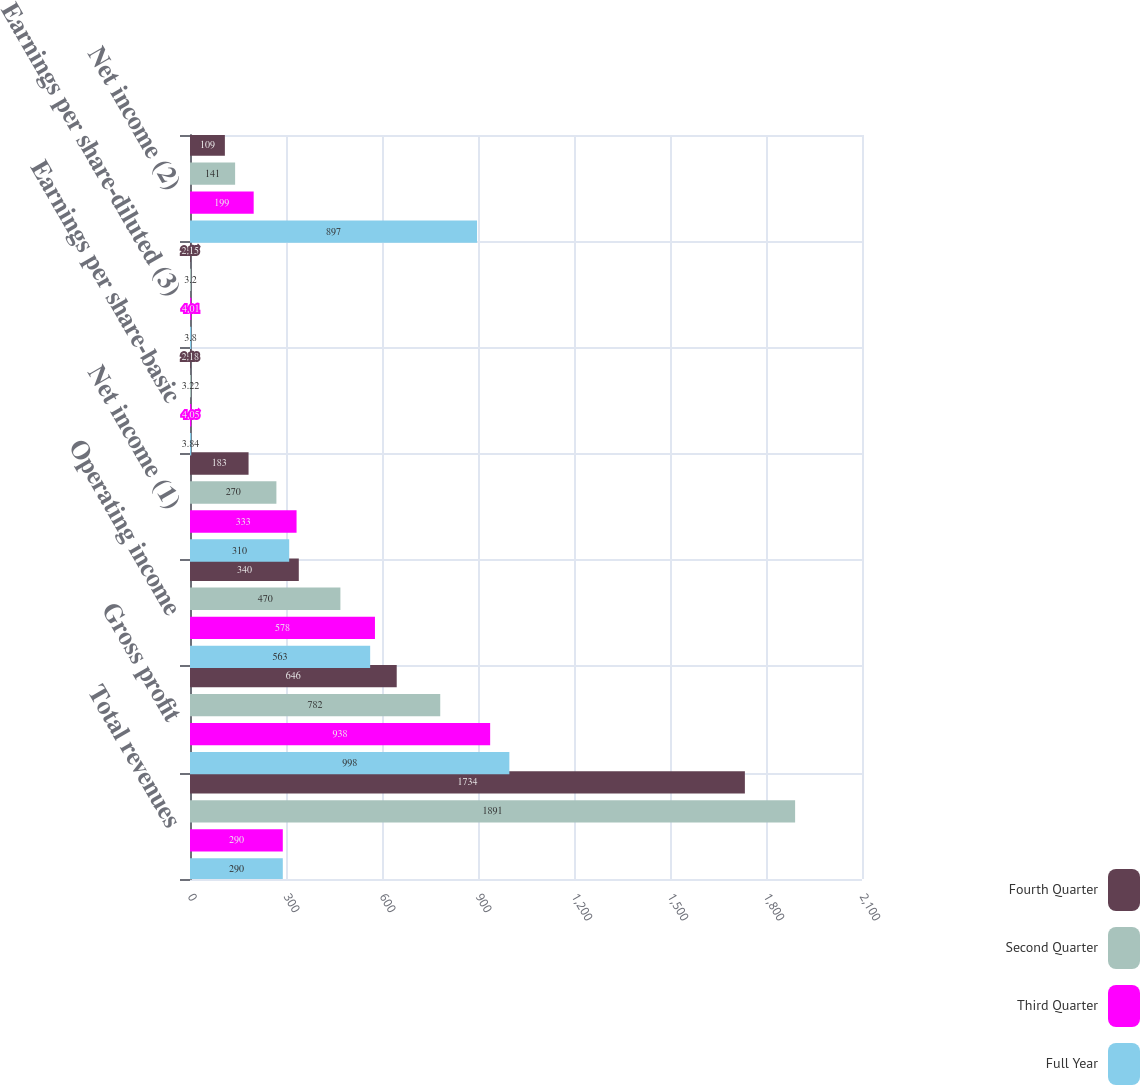<chart> <loc_0><loc_0><loc_500><loc_500><stacked_bar_chart><ecel><fcel>Total revenues<fcel>Gross profit<fcel>Operating income<fcel>Net income (1)<fcel>Earnings per share-basic<fcel>Earnings per share-diluted (3)<fcel>Net income (2)<nl><fcel>Fourth Quarter<fcel>1734<fcel>646<fcel>340<fcel>183<fcel>2.18<fcel>2.15<fcel>109<nl><fcel>Second Quarter<fcel>1891<fcel>782<fcel>470<fcel>270<fcel>3.22<fcel>3.2<fcel>141<nl><fcel>Third Quarter<fcel>290<fcel>938<fcel>578<fcel>333<fcel>4.05<fcel>4.01<fcel>199<nl><fcel>Full Year<fcel>290<fcel>998<fcel>563<fcel>310<fcel>3.84<fcel>3.8<fcel>897<nl></chart> 